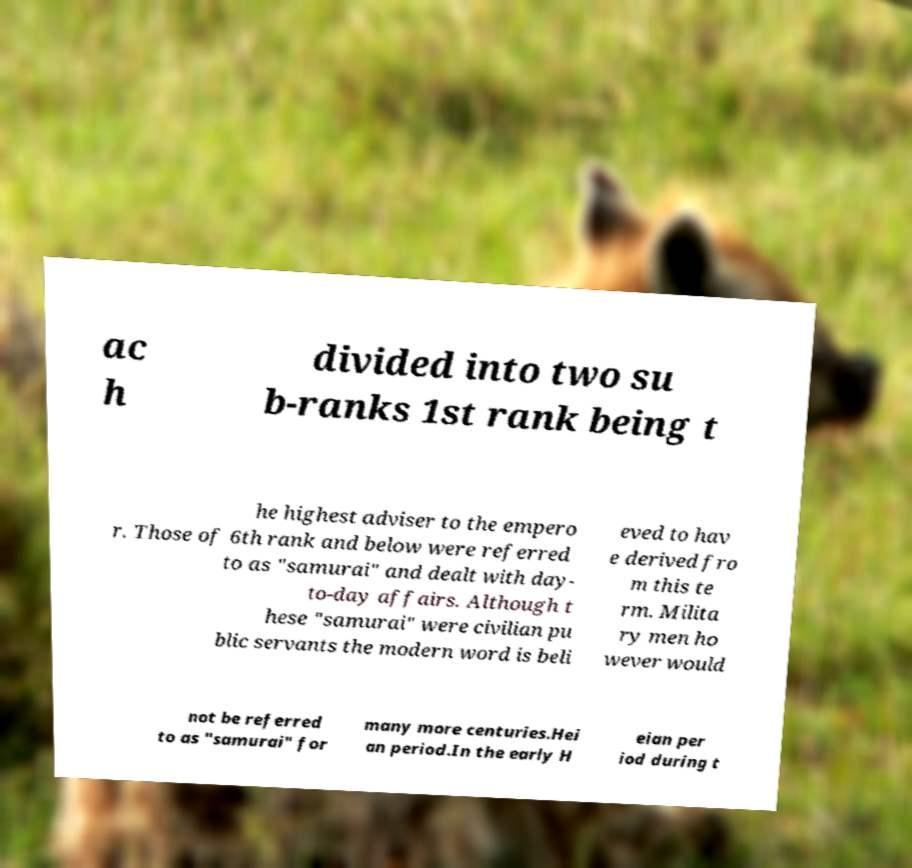Can you accurately transcribe the text from the provided image for me? ac h divided into two su b-ranks 1st rank being t he highest adviser to the empero r. Those of 6th rank and below were referred to as "samurai" and dealt with day- to-day affairs. Although t hese "samurai" were civilian pu blic servants the modern word is beli eved to hav e derived fro m this te rm. Milita ry men ho wever would not be referred to as "samurai" for many more centuries.Hei an period.In the early H eian per iod during t 